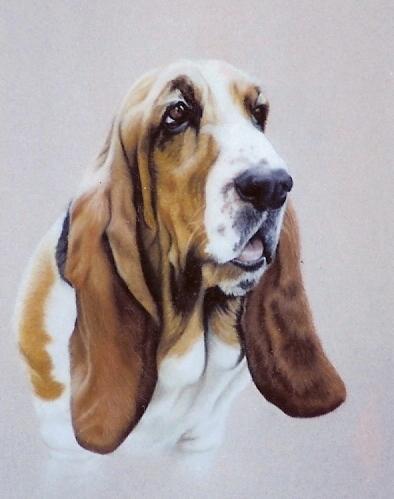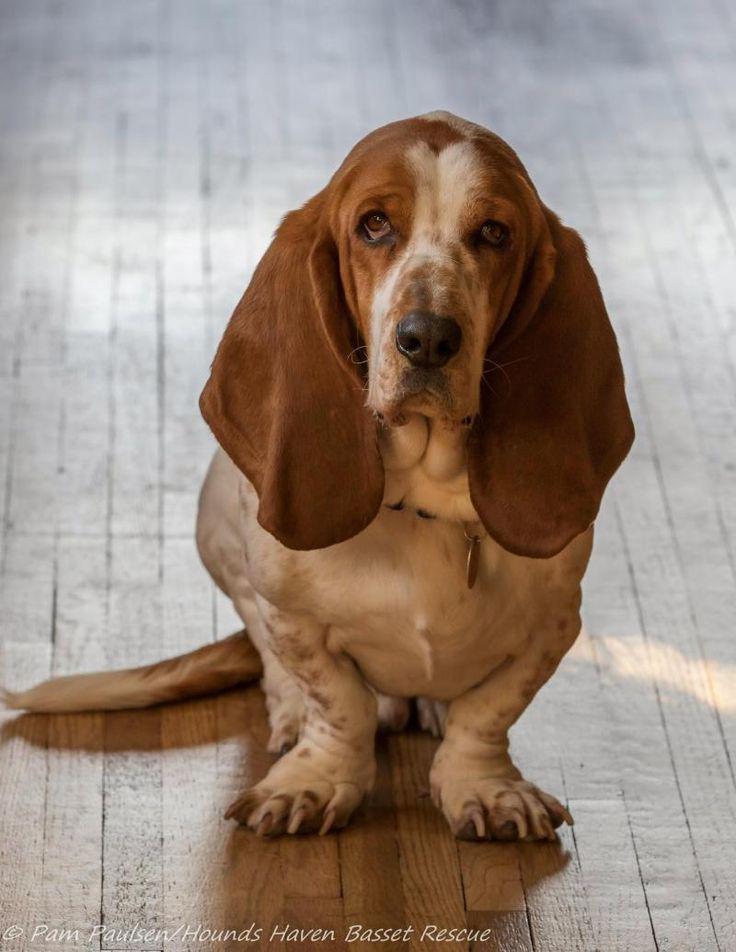The first image is the image on the left, the second image is the image on the right. Analyze the images presented: Is the assertion "One of the dogs is wearing an item of clothing." valid? Answer yes or no. No. The first image is the image on the left, the second image is the image on the right. For the images shown, is this caption "One image shows a forward-facing hound posed indoors wearing some type of outfit that includes a scarf." true? Answer yes or no. No. 